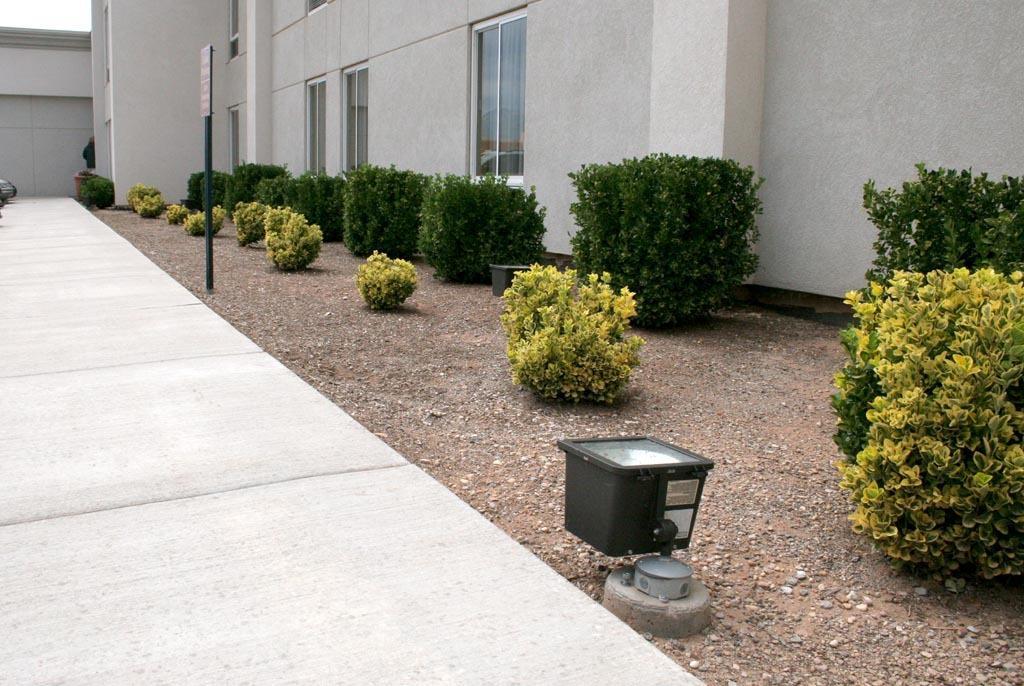Describe this image in one or two sentences. This picture is clicked outside. In the foreground we can see the ground, plants, text on the board which is attached to the pole and we can see some other objects. In the background we can see the building, windows of the building and a person like thing. 